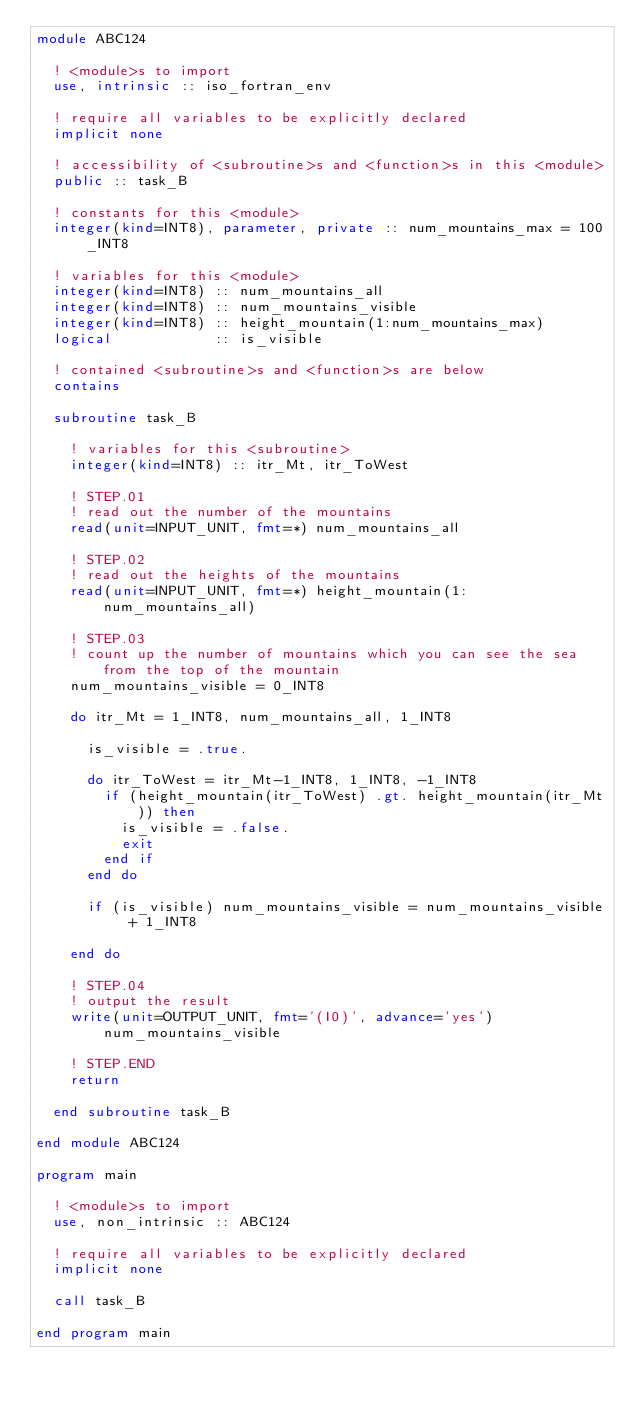<code> <loc_0><loc_0><loc_500><loc_500><_FORTRAN_>module ABC124

  ! <module>s to import
  use, intrinsic :: iso_fortran_env

  ! require all variables to be explicitly declared
  implicit none

  ! accessibility of <subroutine>s and <function>s in this <module>
  public :: task_B

  ! constants for this <module>
  integer(kind=INT8), parameter, private :: num_mountains_max = 100_INT8

  ! variables for this <module>
  integer(kind=INT8) :: num_mountains_all
  integer(kind=INT8) :: num_mountains_visible
  integer(kind=INT8) :: height_mountain(1:num_mountains_max)
  logical            :: is_visible

  ! contained <subroutine>s and <function>s are below
  contains

  subroutine task_B

    ! variables for this <subroutine>
    integer(kind=INT8) :: itr_Mt, itr_ToWest

    ! STEP.01
    ! read out the number of the mountains
    read(unit=INPUT_UNIT, fmt=*) num_mountains_all

    ! STEP.02
    ! read out the heights of the mountains
    read(unit=INPUT_UNIT, fmt=*) height_mountain(1:num_mountains_all)

    ! STEP.03
    ! count up the number of mountains which you can see the sea from the top of the mountain
    num_mountains_visible = 0_INT8

    do itr_Mt = 1_INT8, num_mountains_all, 1_INT8
      
      is_visible = .true.

      do itr_ToWest = itr_Mt-1_INT8, 1_INT8, -1_INT8
        if (height_mountain(itr_ToWest) .gt. height_mountain(itr_Mt)) then
          is_visible = .false.
          exit
        end if
      end do

      if (is_visible) num_mountains_visible = num_mountains_visible + 1_INT8

    end do

    ! STEP.04
    ! output the result
    write(unit=OUTPUT_UNIT, fmt='(I0)', advance='yes') num_mountains_visible

    ! STEP.END
    return

  end subroutine task_B

end module ABC124

program main

  ! <module>s to import
  use, non_intrinsic :: ABC124

  ! require all variables to be explicitly declared
  implicit none

  call task_B

end program main</code> 